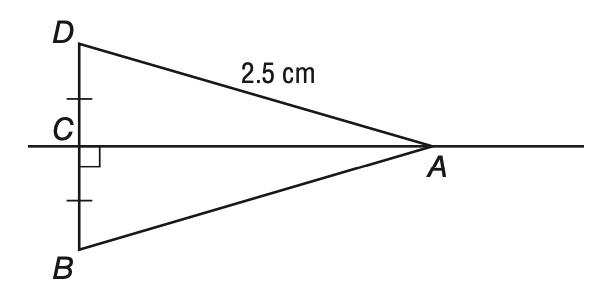Answer the mathemtical geometry problem and directly provide the correct option letter.
Question: According to the Perpendicular Bisector Theorem, what is the length of segment A B below?
Choices: A: 2.5 B: 3.0 C: 4.0 D: 5.0 A 